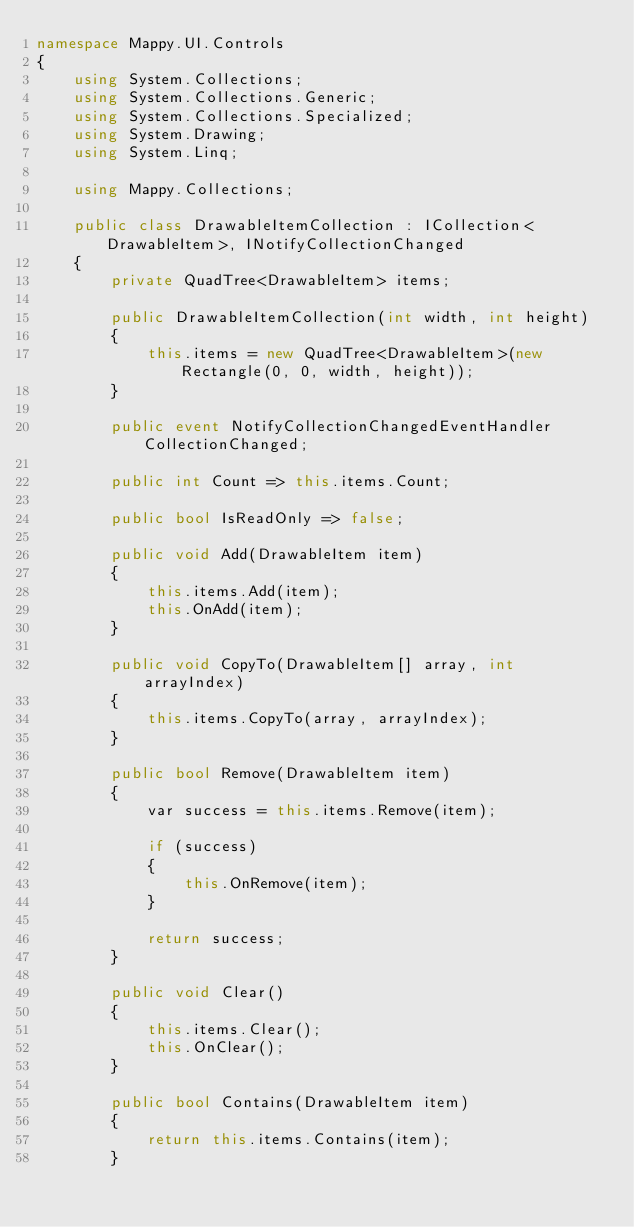<code> <loc_0><loc_0><loc_500><loc_500><_C#_>namespace Mappy.UI.Controls
{
    using System.Collections;
    using System.Collections.Generic;
    using System.Collections.Specialized;
    using System.Drawing;
    using System.Linq;

    using Mappy.Collections;

    public class DrawableItemCollection : ICollection<DrawableItem>, INotifyCollectionChanged
    {
        private QuadTree<DrawableItem> items;

        public DrawableItemCollection(int width, int height)
        {
            this.items = new QuadTree<DrawableItem>(new Rectangle(0, 0, width, height));
        }

        public event NotifyCollectionChangedEventHandler CollectionChanged;

        public int Count => this.items.Count;

        public bool IsReadOnly => false;

        public void Add(DrawableItem item)
        {
            this.items.Add(item);
            this.OnAdd(item);
        }

        public void CopyTo(DrawableItem[] array, int arrayIndex)
        {
            this.items.CopyTo(array, arrayIndex);
        }

        public bool Remove(DrawableItem item)
        {
            var success = this.items.Remove(item);

            if (success)
            {
                this.OnRemove(item);
            }

            return success;
        }

        public void Clear()
        {
            this.items.Clear();
            this.OnClear();
        }

        public bool Contains(DrawableItem item)
        {
            return this.items.Contains(item);
        }
</code> 